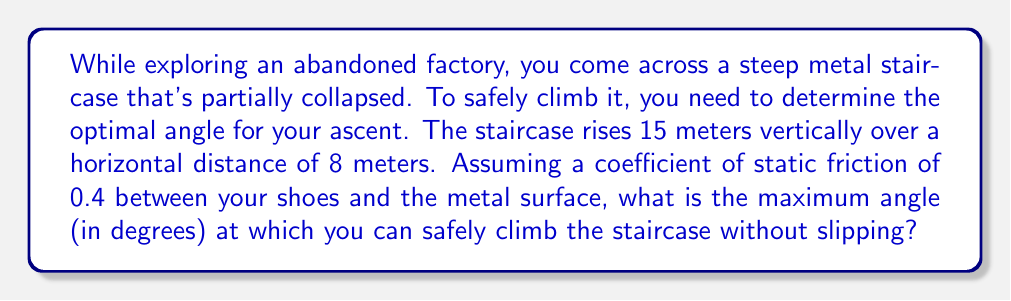Teach me how to tackle this problem. To solve this problem, we'll use trigonometry and the concept of static friction. Let's break it down step by step:

1. First, let's calculate the current angle of the staircase:
   $$\theta = \tan^{-1}\left(\frac{\text{vertical rise}}{\text{horizontal distance}}\right) = \tan^{-1}\left(\frac{15}{8}\right) \approx 61.93^\circ$$

2. Now, we need to determine the maximum angle at which you can climb without slipping. This is related to the coefficient of static friction ($\mu_s$).

3. The maximum angle of inclination before slipping occurs is given by:
   $$\theta_{\max} = \tan^{-1}(\mu_s)$$

4. Given $\mu_s = 0.4$, we can calculate:
   $$\theta_{\max} = \tan^{-1}(0.4) \approx 21.80^\circ$$

5. This means that any surface steeper than 21.80° would be unsafe to climb without additional support or equipment.

6. Comparing this to the actual angle of the staircase (61.93°), we can see that it's much steeper than the safe climbing angle.

7. Therefore, the maximum angle at which you can safely climb is 21.80°.

[asy]
import geometry;

size(200);
draw((0,0)--(100,0), arrow=Arrow(TeXHead));
draw((0,0)--(0,50), arrow=Arrow(TeXHead));
draw((0,0)--(100,40), linewidth(2));
draw((90,0)--(90,36), dashed);
draw((0,0)--(90,36), dashed);

label("$21.80^\circ$", (20,10), NE);
label("Safe climbing angle", (50,30), N);
label("Ground", (50,-5), S);
[/asy]
Answer: The maximum angle for safely climbing the staircase is approximately $21.80^\circ$. 